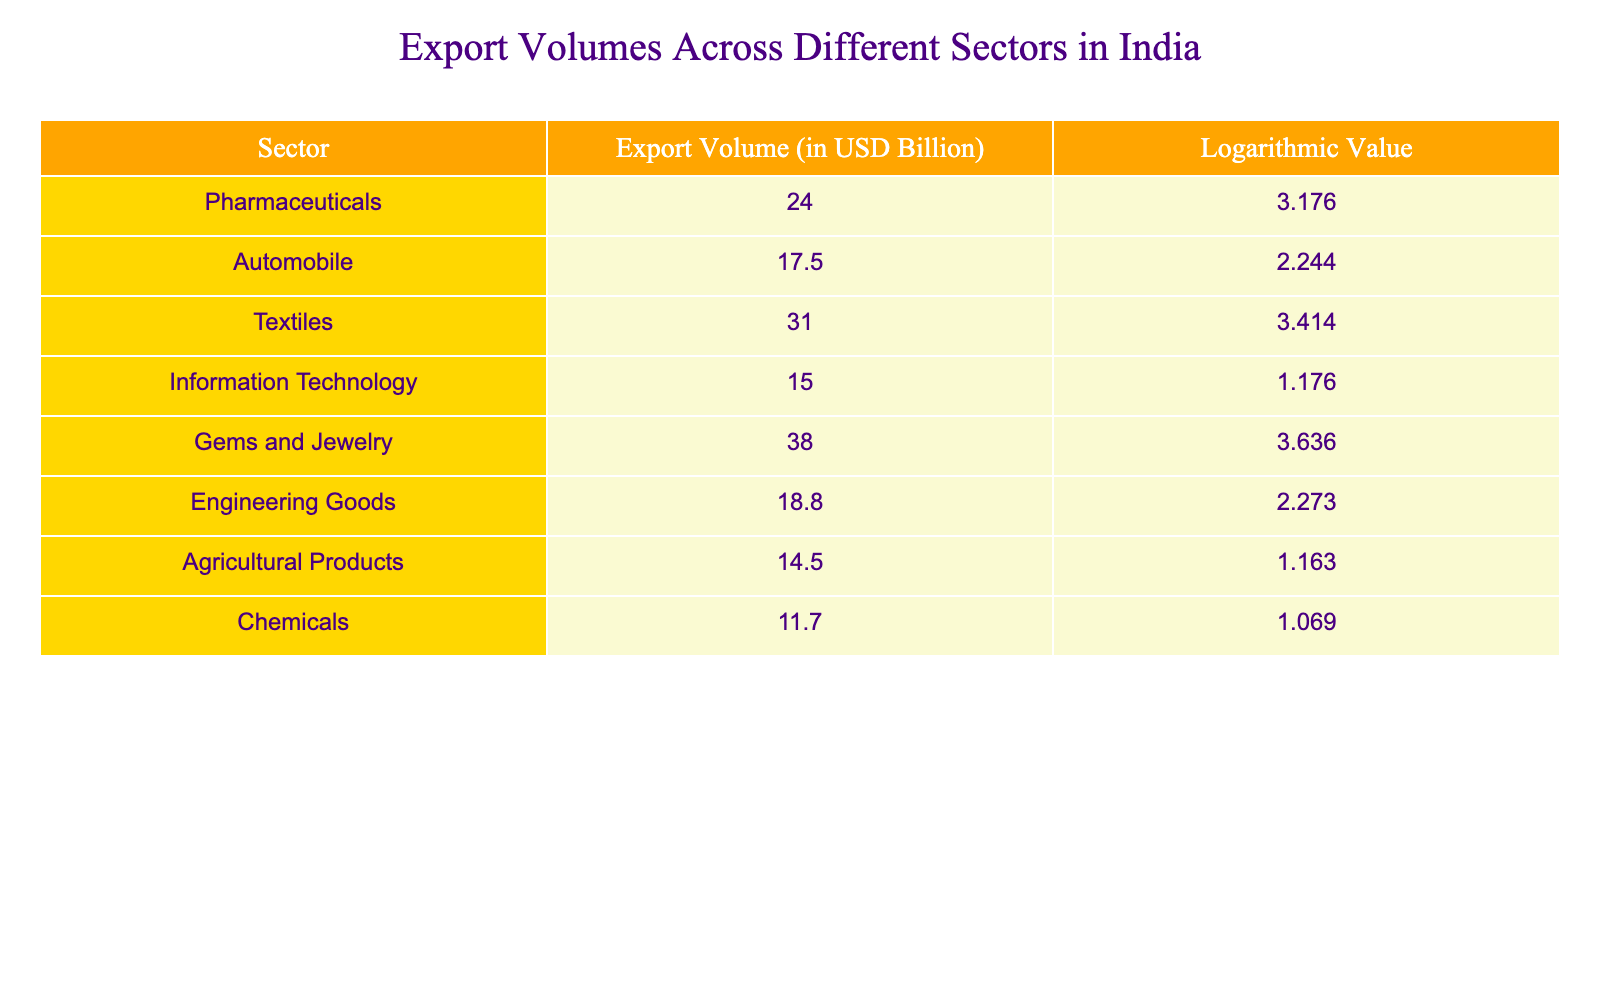What is the export volume of the Textiles sector? The table shows that the export volume for the Textiles sector is listed directly under its corresponding entry, which is 31.0 billion USD.
Answer: 31.0 billion USD Which sector has the highest export volume? By checking the export volumes for all sectors, the Gems and Jewelry sector has the highest export volume at 38.0 billion USD.
Answer: Gems and Jewelry What is the difference in export volume between Pharmaceuticals and Engineering Goods? The export volume for Pharmaceuticals is 24.0 billion USD, and for Engineering Goods, it is 18.8 billion USD. The difference is calculated as 24.0 - 18.8 = 5.2 billion USD.
Answer: 5.2 billion USD Is the export volume of Agricultural Products greater than that of Chemicals? The export volume of Agricultural Products is 14.5 billion USD, while for Chemicals it is 11.7 billion USD. Since 14.5 is greater than 11.7, the answer is yes.
Answer: Yes What is the average export volume of all sectors listed? To find the average, sum all the export volumes: 24.0 + 17.5 + 31.0 + 15.0 + 38.0 + 18.8 + 14.5 + 11.7 = 170.5 billion USD. There are 8 sectors, so the average is 170.5 / 8 = 21.3125 billion USD.
Answer: 21.3125 billion USD Which sectors have an export volume of less than 20 billion USD? Looking through the table, the sectors with export volumes less than 20 billion USD are Automobile (17.5 billion USD), Information Technology (15.0 billion USD), Agricultural Products (14.5 billion USD), and Chemicals (11.7 billion USD).
Answer: Automobile, Information Technology, Agricultural Products, Chemicals What is the log value of the export volume for the Gems and Jewelry sector? The table directly provides the logarithmic value corresponding to the export volume of the Gems and Jewelry sector, which is 3.636.
Answer: 3.636 If you combine the export volumes of the top three sectors, what would that total be? The top three sectors based on export volume are Gems and Jewelry (38.0 billion USD), Textiles (31.0 billion USD), and Pharmaceuticals (24.0 billion USD). Summing these gives 38.0 + 31.0 + 24.0 = 93.0 billion USD.
Answer: 93.0 billion USD What is the total export volume for the sectors with values less than 15 billion USD? From the table, the sectors with export volumes less than 15 billion USD are Information Technology (15.0 billion USD), Agricultural Products (14.5 billion USD), and Chemicals (11.7 billion USD). Adding these gives 14.5 + 11.7 = 26.2 billion USD.
Answer: 26.2 billion USD 